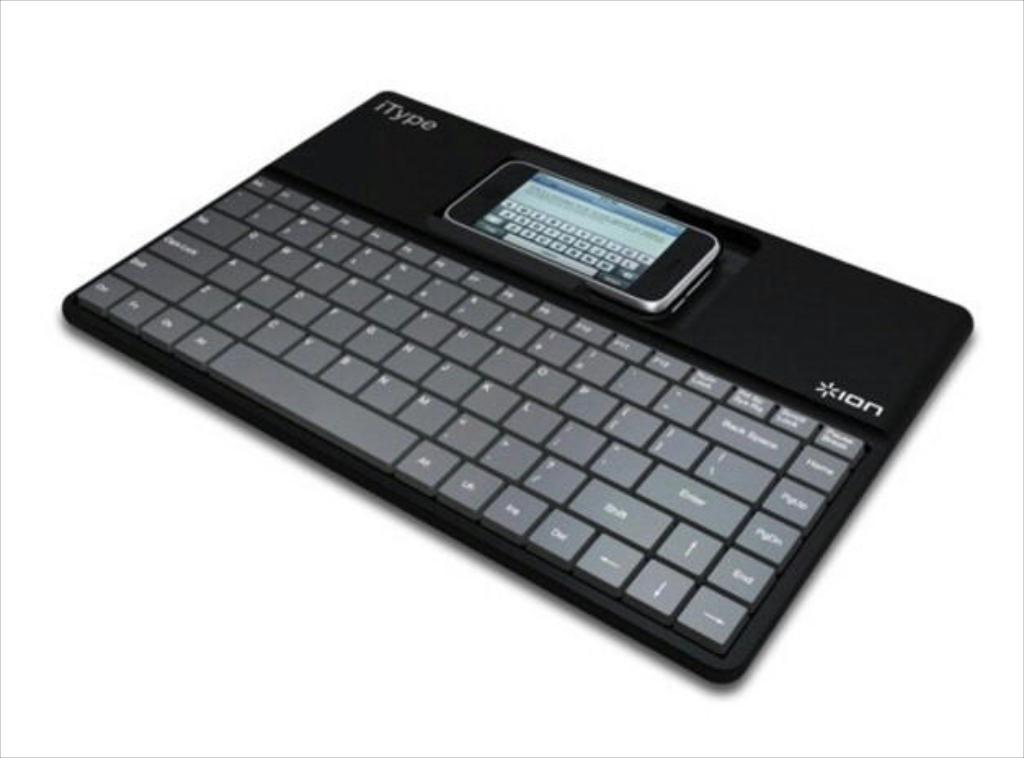<image>
Present a compact description of the photo's key features. The itype keyboard helps you type messages on your smartphone. 